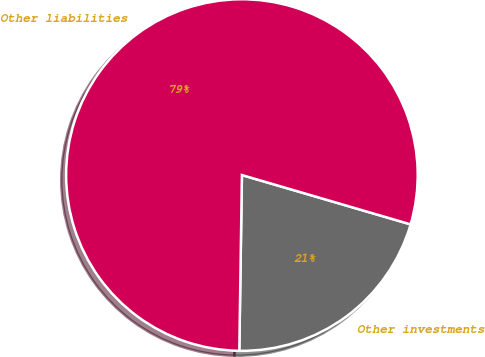Convert chart. <chart><loc_0><loc_0><loc_500><loc_500><pie_chart><fcel>Other investments<fcel>Other liabilities<nl><fcel>20.71%<fcel>79.29%<nl></chart> 